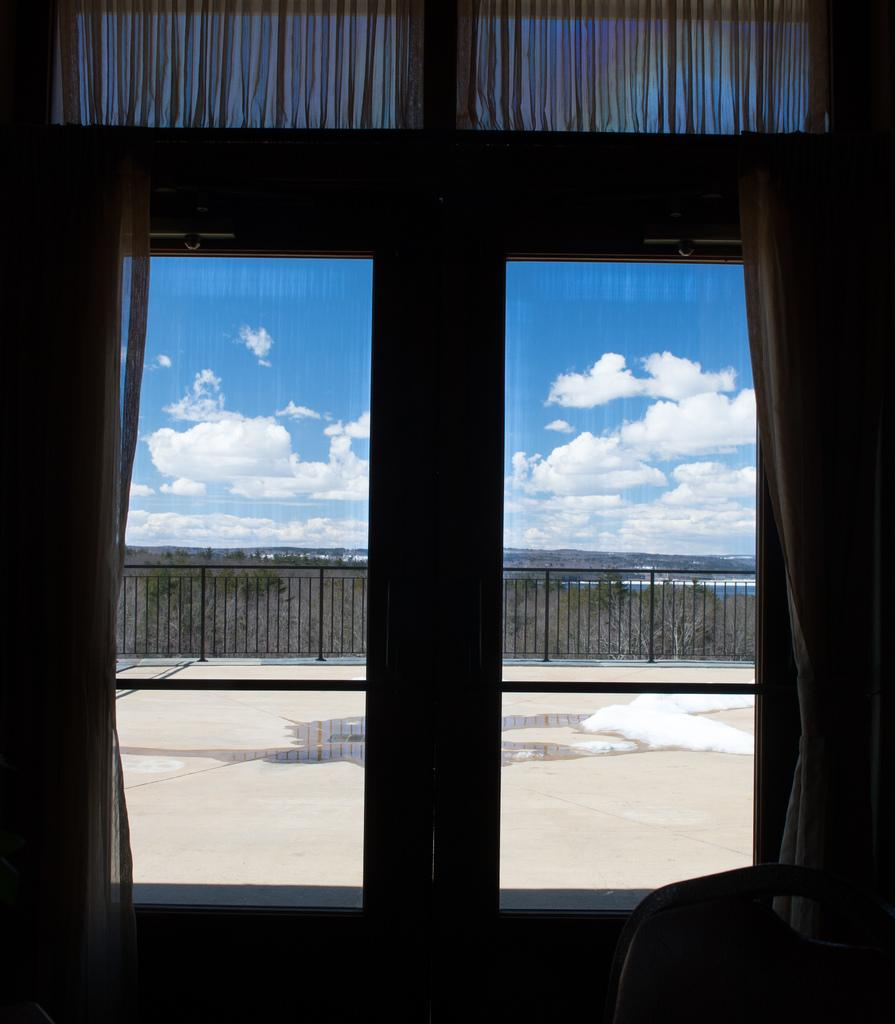What type of window is visible in the image? There is a glass window with curtains in the image. What is on the other side of the glass window? There is a wooden fence on the other side of the glass window. What can be seen in the sky at the top of the image? Clouds are visible in the sky at the top of the image. What type of meat is being served in the image? There is no meat present in the image; it features a glass window with curtains and a wooden fence on the other side. 